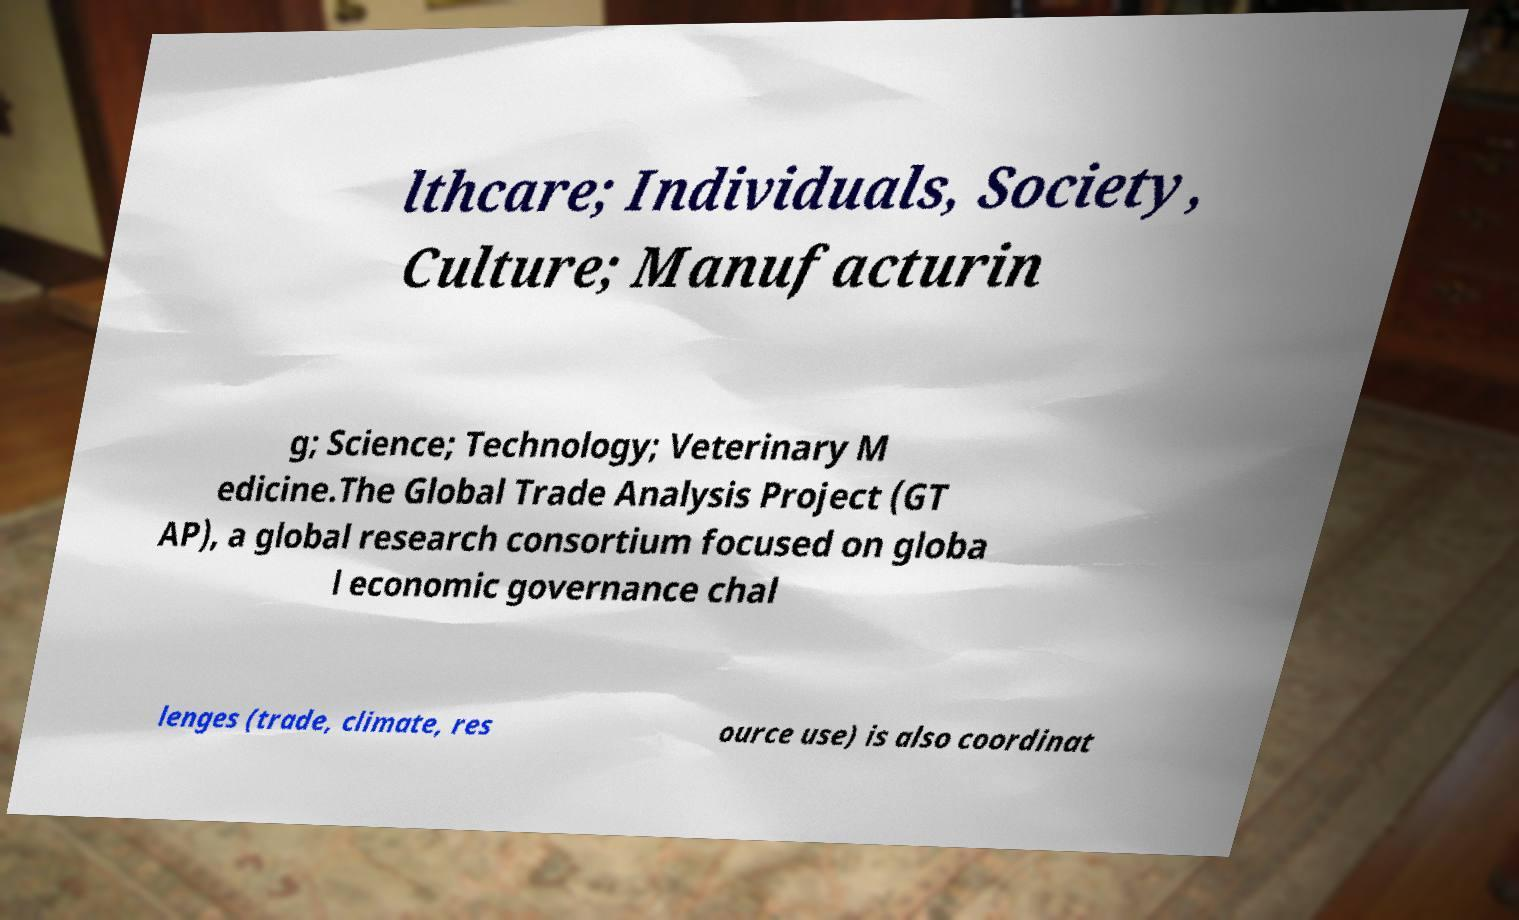Could you assist in decoding the text presented in this image and type it out clearly? lthcare; Individuals, Society, Culture; Manufacturin g; Science; Technology; Veterinary M edicine.The Global Trade Analysis Project (GT AP), a global research consortium focused on globa l economic governance chal lenges (trade, climate, res ource use) is also coordinat 